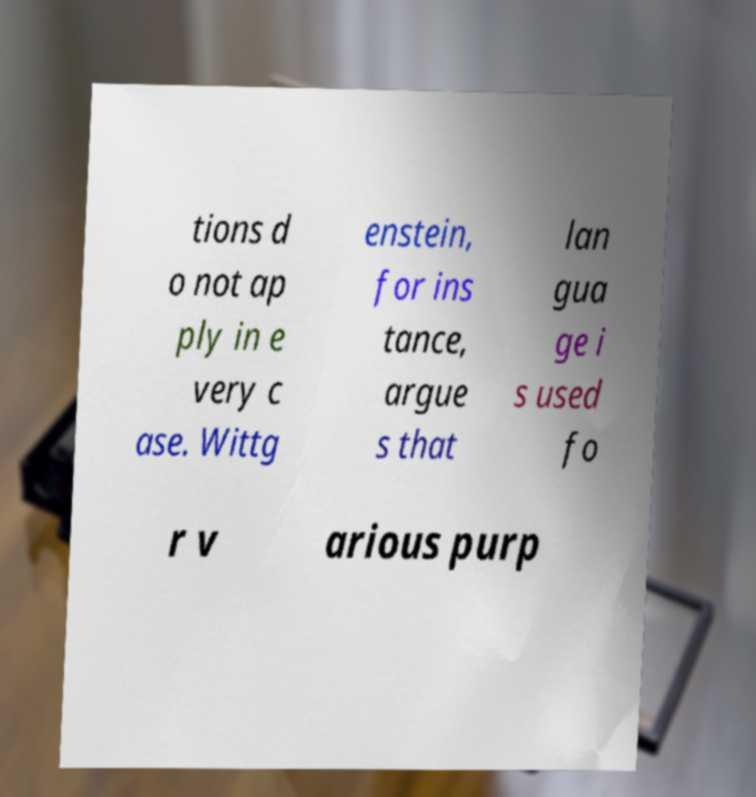Please identify and transcribe the text found in this image. tions d o not ap ply in e very c ase. Wittg enstein, for ins tance, argue s that lan gua ge i s used fo r v arious purp 